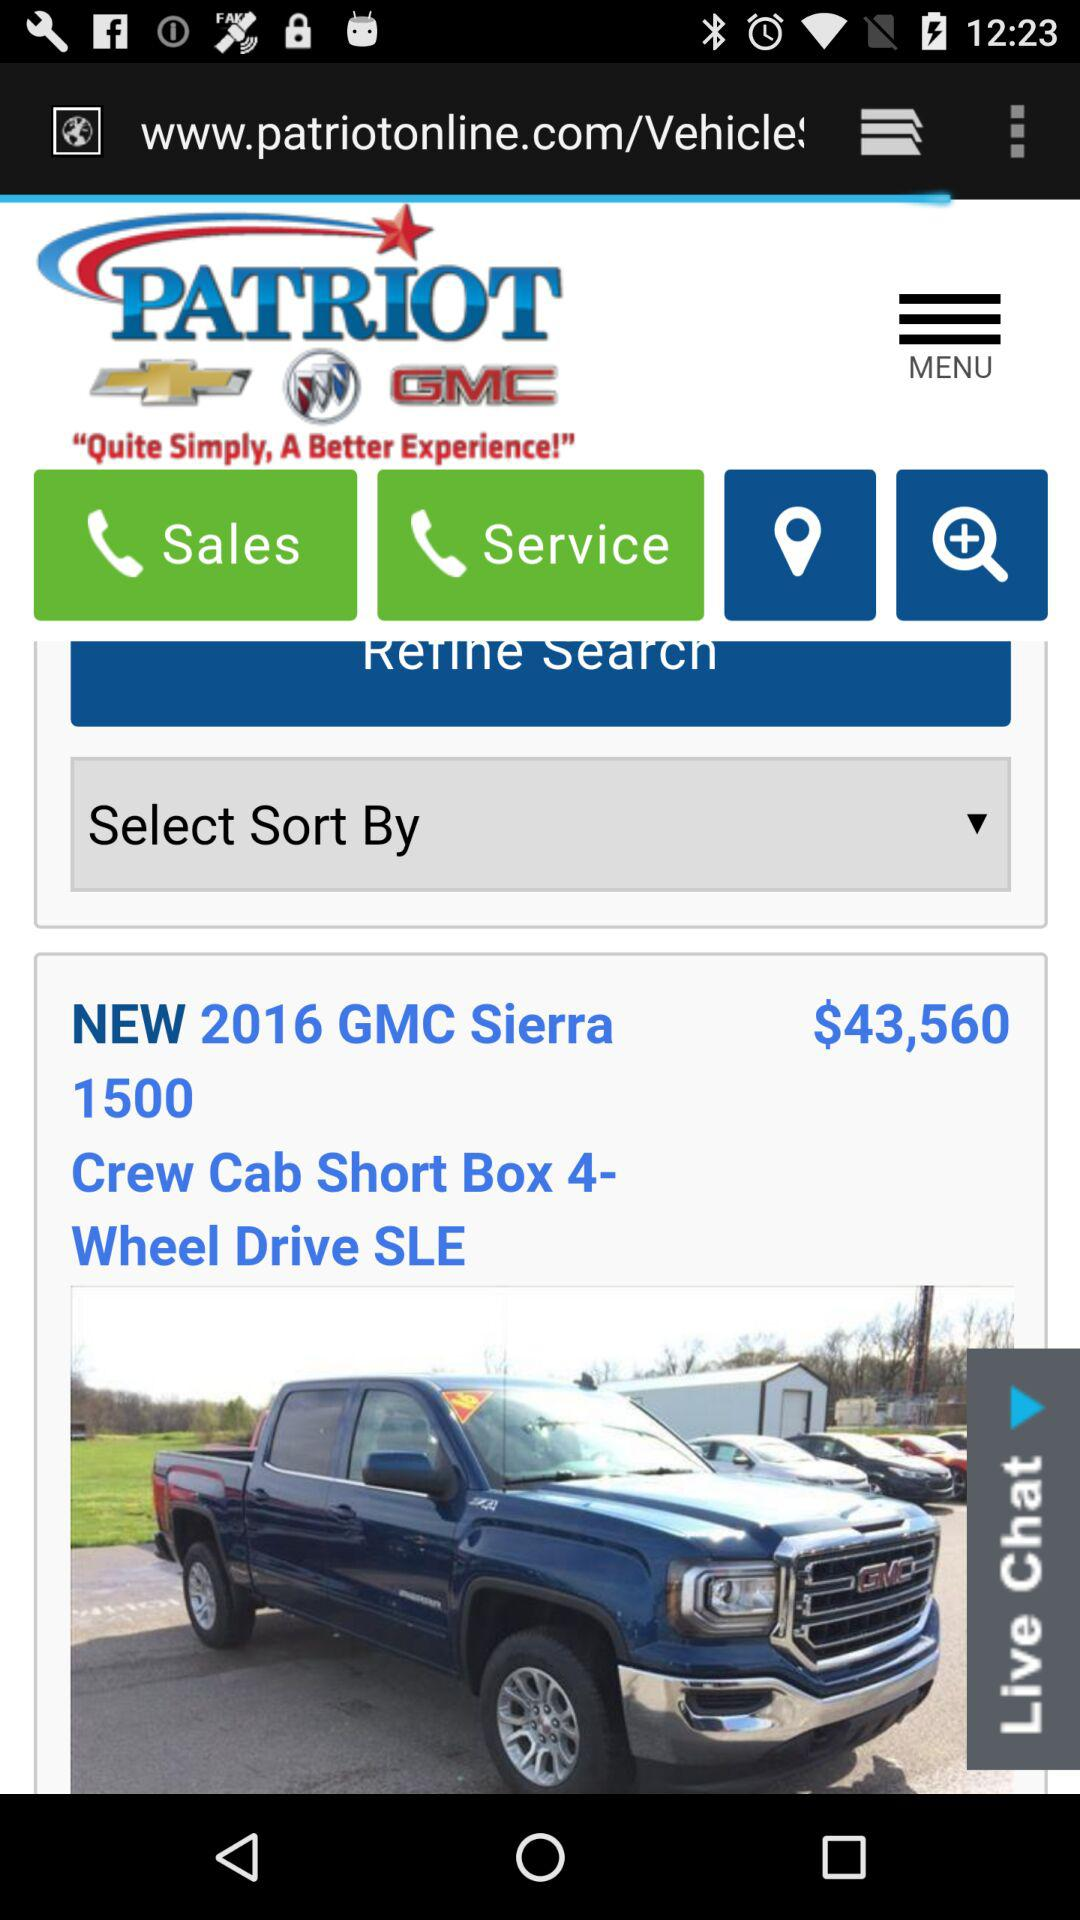What is the name of the application? The name of the application is "PATRIOT". 